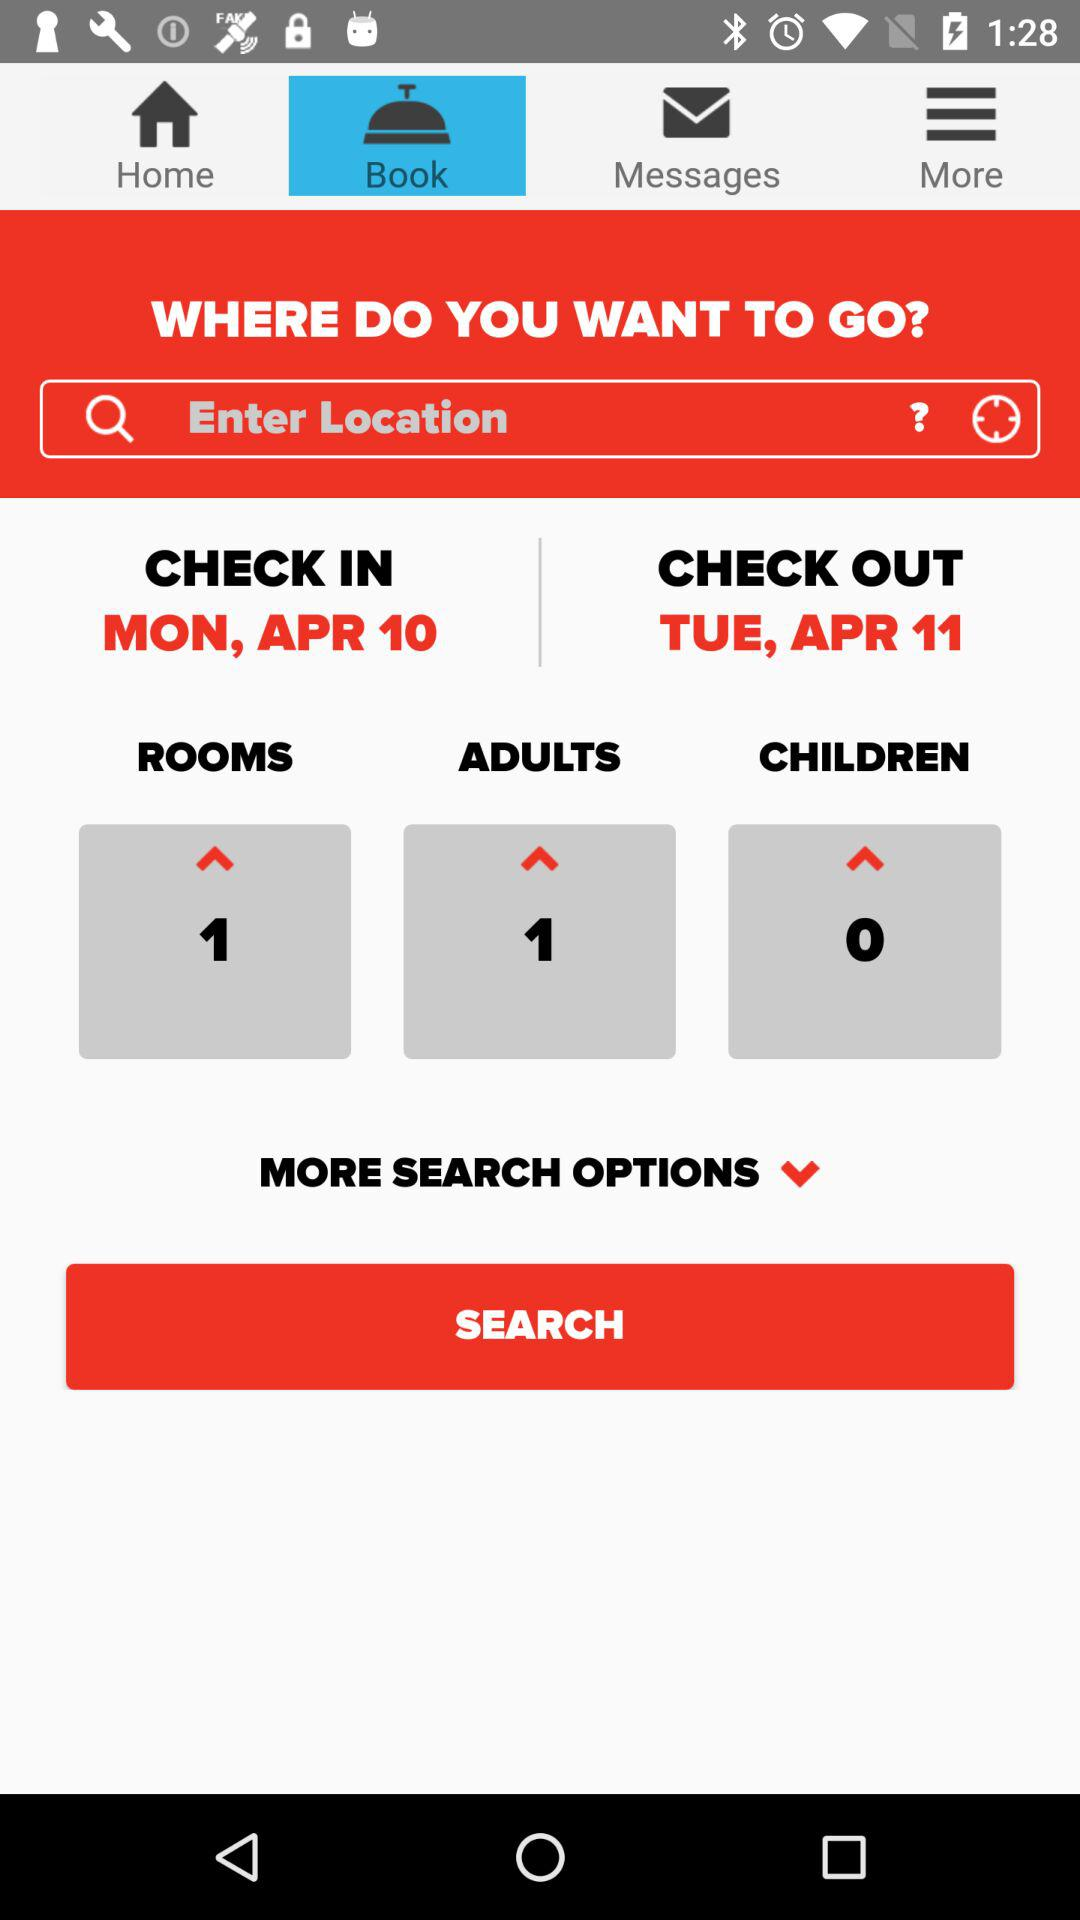How many unread messages are there?
When the provided information is insufficient, respond with <no answer>. <no answer> 